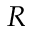Convert formula to latex. <formula><loc_0><loc_0><loc_500><loc_500>R</formula> 